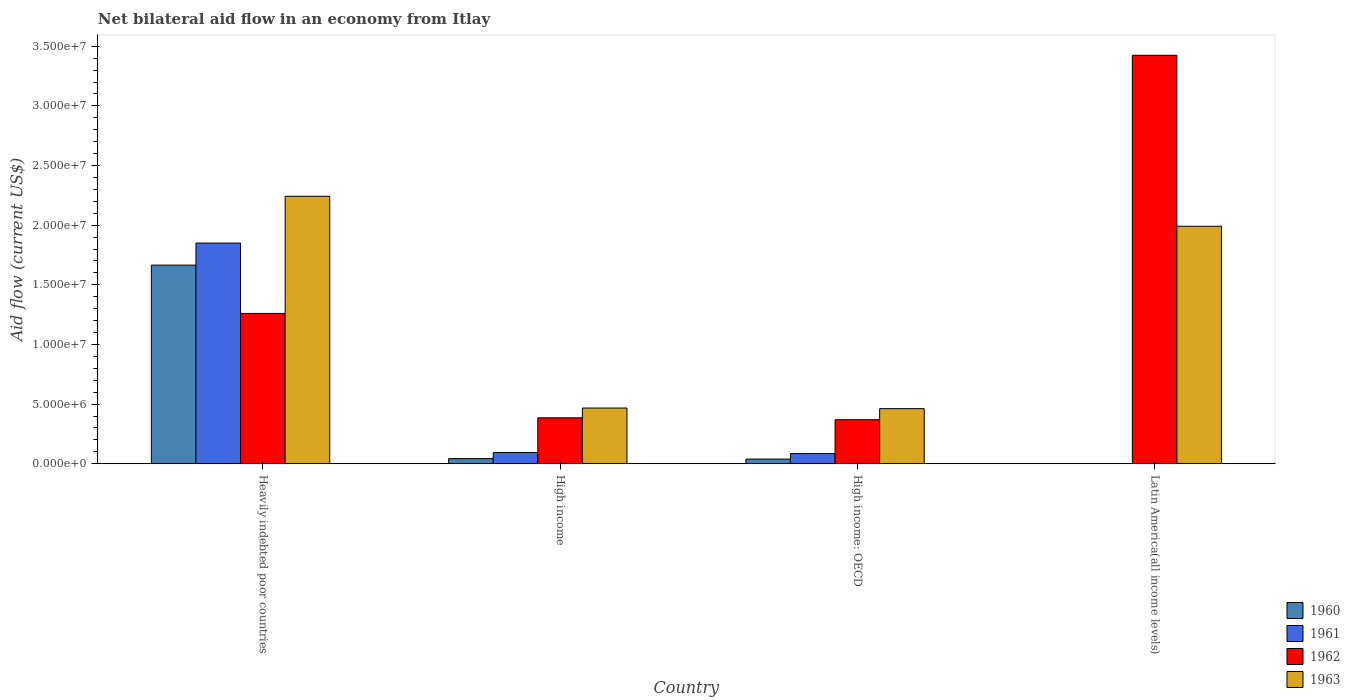How many bars are there on the 4th tick from the left?
Your answer should be compact. 2. How many bars are there on the 2nd tick from the right?
Your answer should be compact. 4. What is the label of the 3rd group of bars from the left?
Provide a short and direct response. High income: OECD. What is the net bilateral aid flow in 1960 in Latin America(all income levels)?
Your response must be concise. 0. Across all countries, what is the maximum net bilateral aid flow in 1962?
Offer a terse response. 3.42e+07. Across all countries, what is the minimum net bilateral aid flow in 1961?
Keep it short and to the point. 0. In which country was the net bilateral aid flow in 1960 maximum?
Provide a succinct answer. Heavily indebted poor countries. What is the total net bilateral aid flow in 1963 in the graph?
Your answer should be very brief. 5.16e+07. What is the difference between the net bilateral aid flow in 1963 in Heavily indebted poor countries and that in High income: OECD?
Give a very brief answer. 1.78e+07. What is the difference between the net bilateral aid flow in 1963 in Latin America(all income levels) and the net bilateral aid flow in 1962 in High income: OECD?
Ensure brevity in your answer.  1.62e+07. What is the average net bilateral aid flow in 1962 per country?
Give a very brief answer. 1.36e+07. What is the difference between the net bilateral aid flow of/in 1962 and net bilateral aid flow of/in 1961 in High income?
Provide a short and direct response. 2.91e+06. In how many countries, is the net bilateral aid flow in 1960 greater than 21000000 US$?
Offer a terse response. 0. What is the ratio of the net bilateral aid flow in 1963 in High income to that in Latin America(all income levels)?
Provide a succinct answer. 0.23. What is the difference between the highest and the second highest net bilateral aid flow in 1962?
Give a very brief answer. 3.04e+07. What is the difference between the highest and the lowest net bilateral aid flow in 1960?
Keep it short and to the point. 1.66e+07. Is the sum of the net bilateral aid flow in 1961 in Heavily indebted poor countries and High income greater than the maximum net bilateral aid flow in 1960 across all countries?
Offer a very short reply. Yes. How many bars are there?
Keep it short and to the point. 14. How many countries are there in the graph?
Make the answer very short. 4. Are the values on the major ticks of Y-axis written in scientific E-notation?
Provide a short and direct response. Yes. Where does the legend appear in the graph?
Offer a terse response. Bottom right. What is the title of the graph?
Your answer should be very brief. Net bilateral aid flow in an economy from Itlay. Does "1977" appear as one of the legend labels in the graph?
Your response must be concise. No. What is the label or title of the X-axis?
Make the answer very short. Country. What is the label or title of the Y-axis?
Your answer should be compact. Aid flow (current US$). What is the Aid flow (current US$) of 1960 in Heavily indebted poor countries?
Provide a short and direct response. 1.66e+07. What is the Aid flow (current US$) of 1961 in Heavily indebted poor countries?
Your answer should be compact. 1.85e+07. What is the Aid flow (current US$) of 1962 in Heavily indebted poor countries?
Provide a succinct answer. 1.26e+07. What is the Aid flow (current US$) of 1963 in Heavily indebted poor countries?
Make the answer very short. 2.24e+07. What is the Aid flow (current US$) in 1961 in High income?
Your answer should be compact. 9.40e+05. What is the Aid flow (current US$) of 1962 in High income?
Keep it short and to the point. 3.85e+06. What is the Aid flow (current US$) of 1963 in High income?
Provide a short and direct response. 4.67e+06. What is the Aid flow (current US$) in 1960 in High income: OECD?
Provide a succinct answer. 3.90e+05. What is the Aid flow (current US$) in 1961 in High income: OECD?
Offer a very short reply. 8.50e+05. What is the Aid flow (current US$) of 1962 in High income: OECD?
Provide a succinct answer. 3.69e+06. What is the Aid flow (current US$) of 1963 in High income: OECD?
Provide a short and direct response. 4.62e+06. What is the Aid flow (current US$) of 1960 in Latin America(all income levels)?
Offer a terse response. 0. What is the Aid flow (current US$) in 1962 in Latin America(all income levels)?
Your response must be concise. 3.42e+07. What is the Aid flow (current US$) in 1963 in Latin America(all income levels)?
Give a very brief answer. 1.99e+07. Across all countries, what is the maximum Aid flow (current US$) in 1960?
Offer a very short reply. 1.66e+07. Across all countries, what is the maximum Aid flow (current US$) of 1961?
Your response must be concise. 1.85e+07. Across all countries, what is the maximum Aid flow (current US$) in 1962?
Your answer should be compact. 3.42e+07. Across all countries, what is the maximum Aid flow (current US$) in 1963?
Give a very brief answer. 2.24e+07. Across all countries, what is the minimum Aid flow (current US$) in 1960?
Offer a terse response. 0. Across all countries, what is the minimum Aid flow (current US$) of 1962?
Make the answer very short. 3.69e+06. Across all countries, what is the minimum Aid flow (current US$) of 1963?
Keep it short and to the point. 4.62e+06. What is the total Aid flow (current US$) in 1960 in the graph?
Offer a terse response. 1.75e+07. What is the total Aid flow (current US$) in 1961 in the graph?
Your answer should be very brief. 2.03e+07. What is the total Aid flow (current US$) of 1962 in the graph?
Your answer should be compact. 5.44e+07. What is the total Aid flow (current US$) in 1963 in the graph?
Ensure brevity in your answer.  5.16e+07. What is the difference between the Aid flow (current US$) in 1960 in Heavily indebted poor countries and that in High income?
Provide a short and direct response. 1.62e+07. What is the difference between the Aid flow (current US$) in 1961 in Heavily indebted poor countries and that in High income?
Your answer should be compact. 1.76e+07. What is the difference between the Aid flow (current US$) of 1962 in Heavily indebted poor countries and that in High income?
Keep it short and to the point. 8.75e+06. What is the difference between the Aid flow (current US$) of 1963 in Heavily indebted poor countries and that in High income?
Make the answer very short. 1.78e+07. What is the difference between the Aid flow (current US$) of 1960 in Heavily indebted poor countries and that in High income: OECD?
Keep it short and to the point. 1.63e+07. What is the difference between the Aid flow (current US$) in 1961 in Heavily indebted poor countries and that in High income: OECD?
Provide a succinct answer. 1.76e+07. What is the difference between the Aid flow (current US$) of 1962 in Heavily indebted poor countries and that in High income: OECD?
Ensure brevity in your answer.  8.91e+06. What is the difference between the Aid flow (current US$) of 1963 in Heavily indebted poor countries and that in High income: OECD?
Your answer should be very brief. 1.78e+07. What is the difference between the Aid flow (current US$) in 1962 in Heavily indebted poor countries and that in Latin America(all income levels)?
Offer a very short reply. -2.16e+07. What is the difference between the Aid flow (current US$) of 1963 in Heavily indebted poor countries and that in Latin America(all income levels)?
Offer a very short reply. 2.51e+06. What is the difference between the Aid flow (current US$) of 1962 in High income and that in High income: OECD?
Ensure brevity in your answer.  1.60e+05. What is the difference between the Aid flow (current US$) of 1962 in High income and that in Latin America(all income levels)?
Your response must be concise. -3.04e+07. What is the difference between the Aid flow (current US$) of 1963 in High income and that in Latin America(all income levels)?
Offer a terse response. -1.52e+07. What is the difference between the Aid flow (current US$) of 1962 in High income: OECD and that in Latin America(all income levels)?
Your answer should be very brief. -3.06e+07. What is the difference between the Aid flow (current US$) of 1963 in High income: OECD and that in Latin America(all income levels)?
Your answer should be compact. -1.53e+07. What is the difference between the Aid flow (current US$) of 1960 in Heavily indebted poor countries and the Aid flow (current US$) of 1961 in High income?
Offer a very short reply. 1.57e+07. What is the difference between the Aid flow (current US$) of 1960 in Heavily indebted poor countries and the Aid flow (current US$) of 1962 in High income?
Ensure brevity in your answer.  1.28e+07. What is the difference between the Aid flow (current US$) in 1960 in Heavily indebted poor countries and the Aid flow (current US$) in 1963 in High income?
Offer a very short reply. 1.20e+07. What is the difference between the Aid flow (current US$) in 1961 in Heavily indebted poor countries and the Aid flow (current US$) in 1962 in High income?
Your answer should be very brief. 1.46e+07. What is the difference between the Aid flow (current US$) of 1961 in Heavily indebted poor countries and the Aid flow (current US$) of 1963 in High income?
Ensure brevity in your answer.  1.38e+07. What is the difference between the Aid flow (current US$) in 1962 in Heavily indebted poor countries and the Aid flow (current US$) in 1963 in High income?
Ensure brevity in your answer.  7.93e+06. What is the difference between the Aid flow (current US$) in 1960 in Heavily indebted poor countries and the Aid flow (current US$) in 1961 in High income: OECD?
Offer a terse response. 1.58e+07. What is the difference between the Aid flow (current US$) of 1960 in Heavily indebted poor countries and the Aid flow (current US$) of 1962 in High income: OECD?
Keep it short and to the point. 1.30e+07. What is the difference between the Aid flow (current US$) in 1960 in Heavily indebted poor countries and the Aid flow (current US$) in 1963 in High income: OECD?
Provide a succinct answer. 1.20e+07. What is the difference between the Aid flow (current US$) of 1961 in Heavily indebted poor countries and the Aid flow (current US$) of 1962 in High income: OECD?
Your answer should be very brief. 1.48e+07. What is the difference between the Aid flow (current US$) in 1961 in Heavily indebted poor countries and the Aid flow (current US$) in 1963 in High income: OECD?
Your answer should be compact. 1.39e+07. What is the difference between the Aid flow (current US$) of 1962 in Heavily indebted poor countries and the Aid flow (current US$) of 1963 in High income: OECD?
Offer a terse response. 7.98e+06. What is the difference between the Aid flow (current US$) in 1960 in Heavily indebted poor countries and the Aid flow (current US$) in 1962 in Latin America(all income levels)?
Your answer should be compact. -1.76e+07. What is the difference between the Aid flow (current US$) in 1960 in Heavily indebted poor countries and the Aid flow (current US$) in 1963 in Latin America(all income levels)?
Make the answer very short. -3.26e+06. What is the difference between the Aid flow (current US$) of 1961 in Heavily indebted poor countries and the Aid flow (current US$) of 1962 in Latin America(all income levels)?
Keep it short and to the point. -1.57e+07. What is the difference between the Aid flow (current US$) of 1961 in Heavily indebted poor countries and the Aid flow (current US$) of 1963 in Latin America(all income levels)?
Ensure brevity in your answer.  -1.41e+06. What is the difference between the Aid flow (current US$) in 1962 in Heavily indebted poor countries and the Aid flow (current US$) in 1963 in Latin America(all income levels)?
Provide a succinct answer. -7.31e+06. What is the difference between the Aid flow (current US$) in 1960 in High income and the Aid flow (current US$) in 1961 in High income: OECD?
Provide a short and direct response. -4.20e+05. What is the difference between the Aid flow (current US$) in 1960 in High income and the Aid flow (current US$) in 1962 in High income: OECD?
Give a very brief answer. -3.26e+06. What is the difference between the Aid flow (current US$) of 1960 in High income and the Aid flow (current US$) of 1963 in High income: OECD?
Make the answer very short. -4.19e+06. What is the difference between the Aid flow (current US$) of 1961 in High income and the Aid flow (current US$) of 1962 in High income: OECD?
Offer a very short reply. -2.75e+06. What is the difference between the Aid flow (current US$) in 1961 in High income and the Aid flow (current US$) in 1963 in High income: OECD?
Your answer should be compact. -3.68e+06. What is the difference between the Aid flow (current US$) in 1962 in High income and the Aid flow (current US$) in 1963 in High income: OECD?
Give a very brief answer. -7.70e+05. What is the difference between the Aid flow (current US$) in 1960 in High income and the Aid flow (current US$) in 1962 in Latin America(all income levels)?
Your answer should be compact. -3.38e+07. What is the difference between the Aid flow (current US$) of 1960 in High income and the Aid flow (current US$) of 1963 in Latin America(all income levels)?
Give a very brief answer. -1.95e+07. What is the difference between the Aid flow (current US$) of 1961 in High income and the Aid flow (current US$) of 1962 in Latin America(all income levels)?
Offer a very short reply. -3.33e+07. What is the difference between the Aid flow (current US$) in 1961 in High income and the Aid flow (current US$) in 1963 in Latin America(all income levels)?
Offer a very short reply. -1.90e+07. What is the difference between the Aid flow (current US$) of 1962 in High income and the Aid flow (current US$) of 1963 in Latin America(all income levels)?
Keep it short and to the point. -1.61e+07. What is the difference between the Aid flow (current US$) in 1960 in High income: OECD and the Aid flow (current US$) in 1962 in Latin America(all income levels)?
Ensure brevity in your answer.  -3.38e+07. What is the difference between the Aid flow (current US$) of 1960 in High income: OECD and the Aid flow (current US$) of 1963 in Latin America(all income levels)?
Make the answer very short. -1.95e+07. What is the difference between the Aid flow (current US$) of 1961 in High income: OECD and the Aid flow (current US$) of 1962 in Latin America(all income levels)?
Give a very brief answer. -3.34e+07. What is the difference between the Aid flow (current US$) of 1961 in High income: OECD and the Aid flow (current US$) of 1963 in Latin America(all income levels)?
Offer a very short reply. -1.91e+07. What is the difference between the Aid flow (current US$) in 1962 in High income: OECD and the Aid flow (current US$) in 1963 in Latin America(all income levels)?
Give a very brief answer. -1.62e+07. What is the average Aid flow (current US$) of 1960 per country?
Keep it short and to the point. 4.37e+06. What is the average Aid flow (current US$) of 1961 per country?
Offer a very short reply. 5.07e+06. What is the average Aid flow (current US$) in 1962 per country?
Provide a short and direct response. 1.36e+07. What is the average Aid flow (current US$) of 1963 per country?
Offer a terse response. 1.29e+07. What is the difference between the Aid flow (current US$) of 1960 and Aid flow (current US$) of 1961 in Heavily indebted poor countries?
Ensure brevity in your answer.  -1.85e+06. What is the difference between the Aid flow (current US$) of 1960 and Aid flow (current US$) of 1962 in Heavily indebted poor countries?
Your answer should be very brief. 4.05e+06. What is the difference between the Aid flow (current US$) of 1960 and Aid flow (current US$) of 1963 in Heavily indebted poor countries?
Your response must be concise. -5.77e+06. What is the difference between the Aid flow (current US$) in 1961 and Aid flow (current US$) in 1962 in Heavily indebted poor countries?
Ensure brevity in your answer.  5.90e+06. What is the difference between the Aid flow (current US$) in 1961 and Aid flow (current US$) in 1963 in Heavily indebted poor countries?
Ensure brevity in your answer.  -3.92e+06. What is the difference between the Aid flow (current US$) of 1962 and Aid flow (current US$) of 1963 in Heavily indebted poor countries?
Your answer should be very brief. -9.82e+06. What is the difference between the Aid flow (current US$) of 1960 and Aid flow (current US$) of 1961 in High income?
Offer a terse response. -5.10e+05. What is the difference between the Aid flow (current US$) in 1960 and Aid flow (current US$) in 1962 in High income?
Your answer should be very brief. -3.42e+06. What is the difference between the Aid flow (current US$) of 1960 and Aid flow (current US$) of 1963 in High income?
Offer a terse response. -4.24e+06. What is the difference between the Aid flow (current US$) in 1961 and Aid flow (current US$) in 1962 in High income?
Your answer should be very brief. -2.91e+06. What is the difference between the Aid flow (current US$) in 1961 and Aid flow (current US$) in 1963 in High income?
Provide a succinct answer. -3.73e+06. What is the difference between the Aid flow (current US$) of 1962 and Aid flow (current US$) of 1963 in High income?
Your answer should be compact. -8.20e+05. What is the difference between the Aid flow (current US$) of 1960 and Aid flow (current US$) of 1961 in High income: OECD?
Ensure brevity in your answer.  -4.60e+05. What is the difference between the Aid flow (current US$) in 1960 and Aid flow (current US$) in 1962 in High income: OECD?
Provide a short and direct response. -3.30e+06. What is the difference between the Aid flow (current US$) of 1960 and Aid flow (current US$) of 1963 in High income: OECD?
Your answer should be very brief. -4.23e+06. What is the difference between the Aid flow (current US$) in 1961 and Aid flow (current US$) in 1962 in High income: OECD?
Your answer should be compact. -2.84e+06. What is the difference between the Aid flow (current US$) of 1961 and Aid flow (current US$) of 1963 in High income: OECD?
Offer a very short reply. -3.77e+06. What is the difference between the Aid flow (current US$) in 1962 and Aid flow (current US$) in 1963 in High income: OECD?
Offer a terse response. -9.30e+05. What is the difference between the Aid flow (current US$) in 1962 and Aid flow (current US$) in 1963 in Latin America(all income levels)?
Your answer should be very brief. 1.43e+07. What is the ratio of the Aid flow (current US$) of 1960 in Heavily indebted poor countries to that in High income?
Your answer should be very brief. 38.72. What is the ratio of the Aid flow (current US$) in 1961 in Heavily indebted poor countries to that in High income?
Offer a terse response. 19.68. What is the ratio of the Aid flow (current US$) of 1962 in Heavily indebted poor countries to that in High income?
Offer a terse response. 3.27. What is the ratio of the Aid flow (current US$) of 1963 in Heavily indebted poor countries to that in High income?
Give a very brief answer. 4.8. What is the ratio of the Aid flow (current US$) of 1960 in Heavily indebted poor countries to that in High income: OECD?
Your answer should be very brief. 42.69. What is the ratio of the Aid flow (current US$) of 1961 in Heavily indebted poor countries to that in High income: OECD?
Offer a terse response. 21.76. What is the ratio of the Aid flow (current US$) in 1962 in Heavily indebted poor countries to that in High income: OECD?
Your answer should be compact. 3.41. What is the ratio of the Aid flow (current US$) of 1963 in Heavily indebted poor countries to that in High income: OECD?
Offer a very short reply. 4.85. What is the ratio of the Aid flow (current US$) of 1962 in Heavily indebted poor countries to that in Latin America(all income levels)?
Provide a short and direct response. 0.37. What is the ratio of the Aid flow (current US$) of 1963 in Heavily indebted poor countries to that in Latin America(all income levels)?
Your answer should be very brief. 1.13. What is the ratio of the Aid flow (current US$) in 1960 in High income to that in High income: OECD?
Offer a very short reply. 1.1. What is the ratio of the Aid flow (current US$) in 1961 in High income to that in High income: OECD?
Provide a succinct answer. 1.11. What is the ratio of the Aid flow (current US$) of 1962 in High income to that in High income: OECD?
Give a very brief answer. 1.04. What is the ratio of the Aid flow (current US$) in 1963 in High income to that in High income: OECD?
Provide a succinct answer. 1.01. What is the ratio of the Aid flow (current US$) of 1962 in High income to that in Latin America(all income levels)?
Your answer should be compact. 0.11. What is the ratio of the Aid flow (current US$) in 1963 in High income to that in Latin America(all income levels)?
Offer a terse response. 0.23. What is the ratio of the Aid flow (current US$) of 1962 in High income: OECD to that in Latin America(all income levels)?
Provide a short and direct response. 0.11. What is the ratio of the Aid flow (current US$) in 1963 in High income: OECD to that in Latin America(all income levels)?
Offer a very short reply. 0.23. What is the difference between the highest and the second highest Aid flow (current US$) in 1960?
Provide a short and direct response. 1.62e+07. What is the difference between the highest and the second highest Aid flow (current US$) in 1961?
Your answer should be very brief. 1.76e+07. What is the difference between the highest and the second highest Aid flow (current US$) of 1962?
Your answer should be very brief. 2.16e+07. What is the difference between the highest and the second highest Aid flow (current US$) in 1963?
Keep it short and to the point. 2.51e+06. What is the difference between the highest and the lowest Aid flow (current US$) of 1960?
Offer a very short reply. 1.66e+07. What is the difference between the highest and the lowest Aid flow (current US$) of 1961?
Give a very brief answer. 1.85e+07. What is the difference between the highest and the lowest Aid flow (current US$) of 1962?
Ensure brevity in your answer.  3.06e+07. What is the difference between the highest and the lowest Aid flow (current US$) of 1963?
Give a very brief answer. 1.78e+07. 